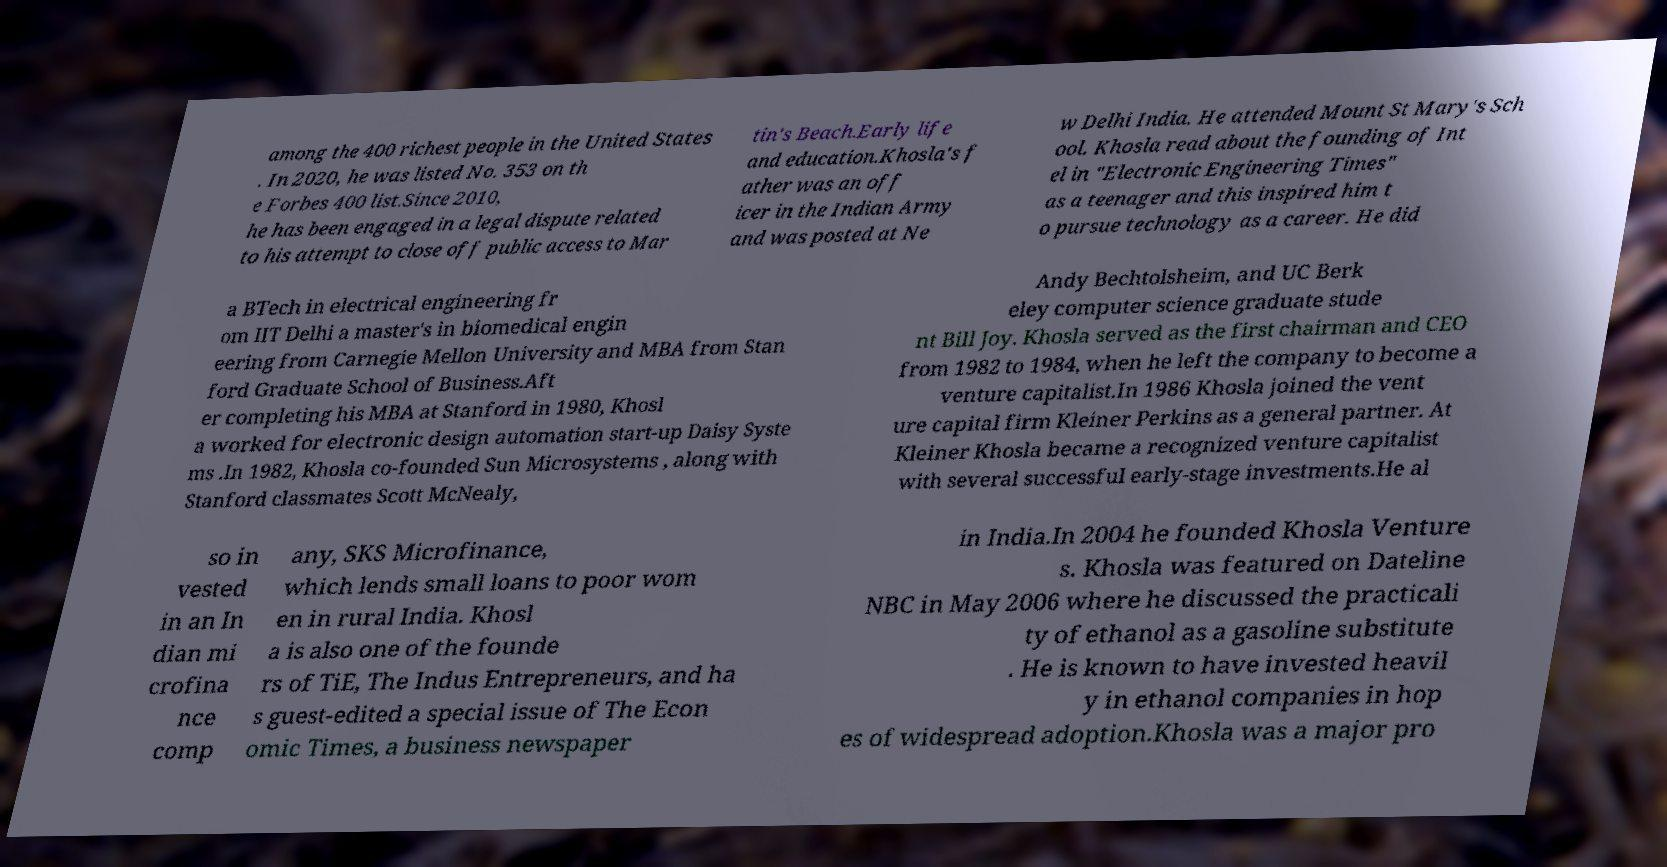I need the written content from this picture converted into text. Can you do that? among the 400 richest people in the United States . In 2020, he was listed No. 353 on th e Forbes 400 list.Since 2010, he has been engaged in a legal dispute related to his attempt to close off public access to Mar tin's Beach.Early life and education.Khosla's f ather was an off icer in the Indian Army and was posted at Ne w Delhi India. He attended Mount St Mary's Sch ool. Khosla read about the founding of Int el in "Electronic Engineering Times" as a teenager and this inspired him t o pursue technology as a career. He did a BTech in electrical engineering fr om IIT Delhi a master's in biomedical engin eering from Carnegie Mellon University and MBA from Stan ford Graduate School of Business.Aft er completing his MBA at Stanford in 1980, Khosl a worked for electronic design automation start-up Daisy Syste ms .In 1982, Khosla co-founded Sun Microsystems , along with Stanford classmates Scott McNealy, Andy Bechtolsheim, and UC Berk eley computer science graduate stude nt Bill Joy. Khosla served as the first chairman and CEO from 1982 to 1984, when he left the company to become a venture capitalist.In 1986 Khosla joined the vent ure capital firm Kleiner Perkins as a general partner. At Kleiner Khosla became a recognized venture capitalist with several successful early-stage investments.He al so in vested in an In dian mi crofina nce comp any, SKS Microfinance, which lends small loans to poor wom en in rural India. Khosl a is also one of the founde rs of TiE, The Indus Entrepreneurs, and ha s guest-edited a special issue of The Econ omic Times, a business newspaper in India.In 2004 he founded Khosla Venture s. Khosla was featured on Dateline NBC in May 2006 where he discussed the practicali ty of ethanol as a gasoline substitute . He is known to have invested heavil y in ethanol companies in hop es of widespread adoption.Khosla was a major pro 